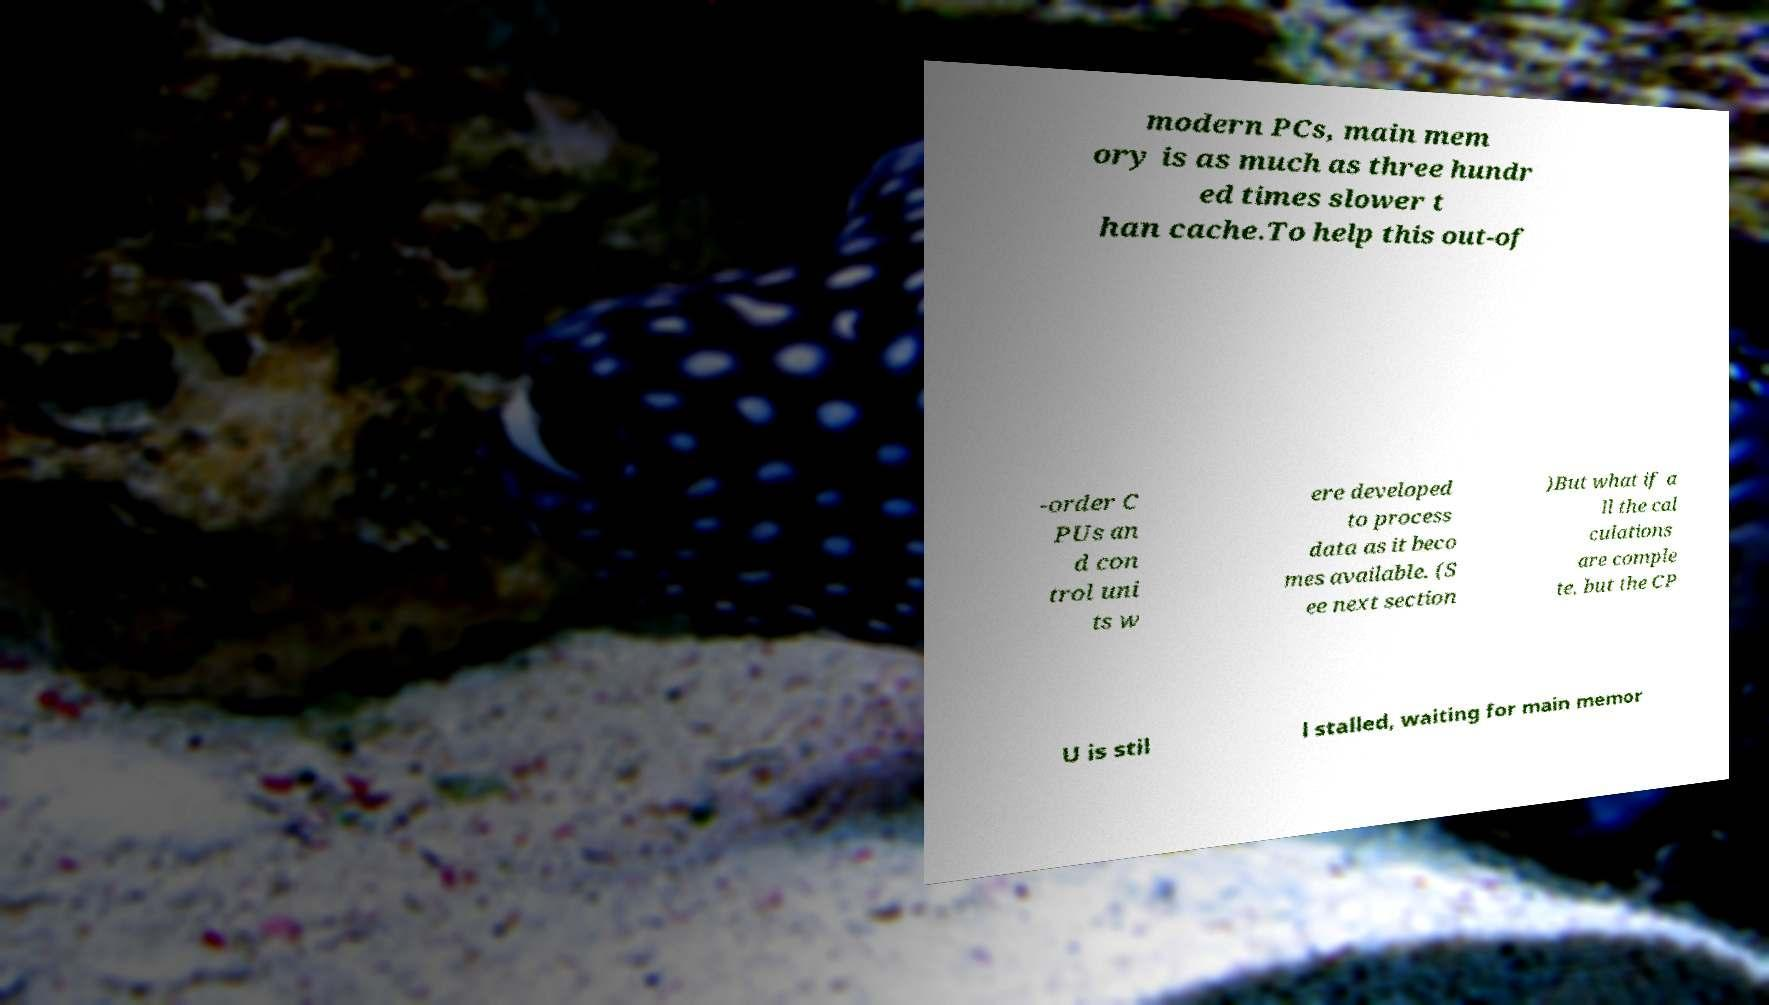There's text embedded in this image that I need extracted. Can you transcribe it verbatim? modern PCs, main mem ory is as much as three hundr ed times slower t han cache.To help this out-of -order C PUs an d con trol uni ts w ere developed to process data as it beco mes available. (S ee next section )But what if a ll the cal culations are comple te, but the CP U is stil l stalled, waiting for main memor 